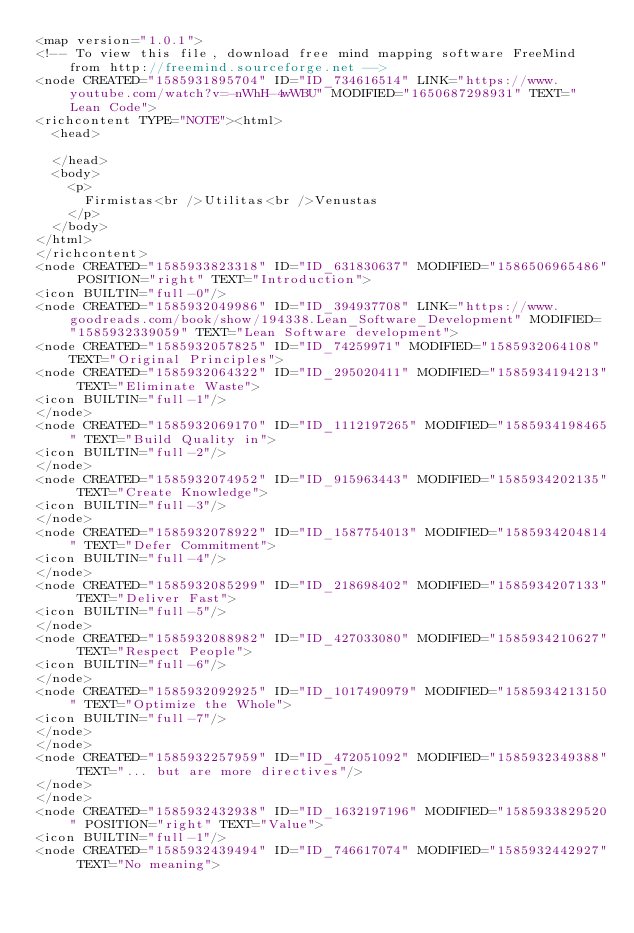<code> <loc_0><loc_0><loc_500><loc_500><_ObjectiveC_><map version="1.0.1">
<!-- To view this file, download free mind mapping software FreeMind from http://freemind.sourceforge.net -->
<node CREATED="1585931895704" ID="ID_734616514" LINK="https://www.youtube.com/watch?v=-nWhH-4wWBU" MODIFIED="1650687298931" TEXT="Lean Code">
<richcontent TYPE="NOTE"><html>
  <head>
    
  </head>
  <body>
    <p>
      Firmistas<br />Utilitas<br />Venustas
    </p>
  </body>
</html>
</richcontent>
<node CREATED="1585933823318" ID="ID_631830637" MODIFIED="1586506965486" POSITION="right" TEXT="Introduction">
<icon BUILTIN="full-0"/>
<node CREATED="1585932049986" ID="ID_394937708" LINK="https://www.goodreads.com/book/show/194338.Lean_Software_Development" MODIFIED="1585932339059" TEXT="Lean Software development">
<node CREATED="1585932057825" ID="ID_74259971" MODIFIED="1585932064108" TEXT="Original Principles">
<node CREATED="1585932064322" ID="ID_295020411" MODIFIED="1585934194213" TEXT="Eliminate Waste">
<icon BUILTIN="full-1"/>
</node>
<node CREATED="1585932069170" ID="ID_1112197265" MODIFIED="1585934198465" TEXT="Build Quality in">
<icon BUILTIN="full-2"/>
</node>
<node CREATED="1585932074952" ID="ID_915963443" MODIFIED="1585934202135" TEXT="Create Knowledge">
<icon BUILTIN="full-3"/>
</node>
<node CREATED="1585932078922" ID="ID_1587754013" MODIFIED="1585934204814" TEXT="Defer Commitment">
<icon BUILTIN="full-4"/>
</node>
<node CREATED="1585932085299" ID="ID_218698402" MODIFIED="1585934207133" TEXT="Deliver Fast">
<icon BUILTIN="full-5"/>
</node>
<node CREATED="1585932088982" ID="ID_427033080" MODIFIED="1585934210627" TEXT="Respect People">
<icon BUILTIN="full-6"/>
</node>
<node CREATED="1585932092925" ID="ID_1017490979" MODIFIED="1585934213150" TEXT="Optimize the Whole">
<icon BUILTIN="full-7"/>
</node>
</node>
<node CREATED="1585932257959" ID="ID_472051092" MODIFIED="1585932349388" TEXT="... but are more directives"/>
</node>
</node>
<node CREATED="1585932432938" ID="ID_1632197196" MODIFIED="1585933829520" POSITION="right" TEXT="Value">
<icon BUILTIN="full-1"/>
<node CREATED="1585932439494" ID="ID_746617074" MODIFIED="1585932442927" TEXT="No meaning"></code> 